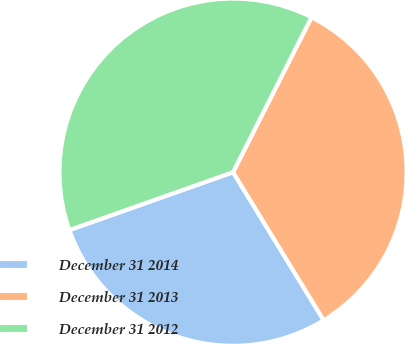<chart> <loc_0><loc_0><loc_500><loc_500><pie_chart><fcel>December 31 2014<fcel>December 31 2013<fcel>December 31 2012<nl><fcel>28.33%<fcel>33.8%<fcel>37.87%<nl></chart> 